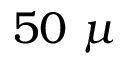<formula> <loc_0><loc_0><loc_500><loc_500>5 0 \mu</formula> 